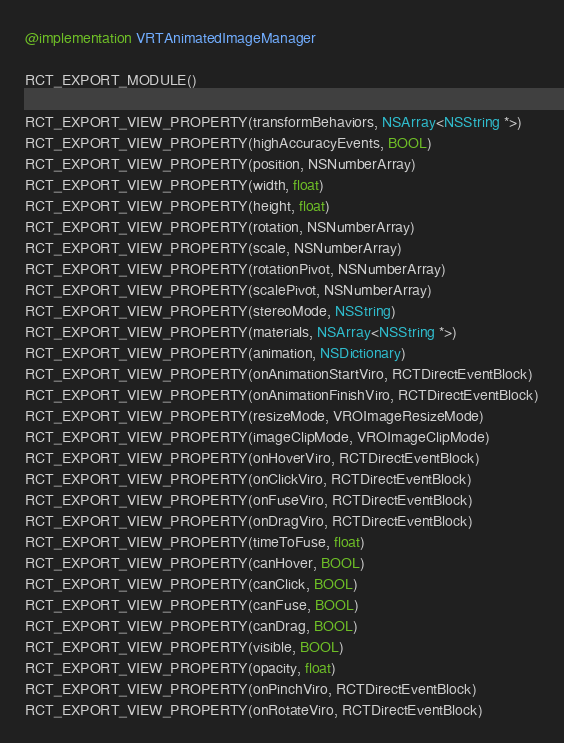Convert code to text. <code><loc_0><loc_0><loc_500><loc_500><_ObjectiveC_>
@implementation VRTAnimatedImageManager

RCT_EXPORT_MODULE()

RCT_EXPORT_VIEW_PROPERTY(transformBehaviors, NSArray<NSString *>)
RCT_EXPORT_VIEW_PROPERTY(highAccuracyEvents, BOOL)
RCT_EXPORT_VIEW_PROPERTY(position, NSNumberArray)
RCT_EXPORT_VIEW_PROPERTY(width, float)
RCT_EXPORT_VIEW_PROPERTY(height, float)
RCT_EXPORT_VIEW_PROPERTY(rotation, NSNumberArray)
RCT_EXPORT_VIEW_PROPERTY(scale, NSNumberArray)
RCT_EXPORT_VIEW_PROPERTY(rotationPivot, NSNumberArray)
RCT_EXPORT_VIEW_PROPERTY(scalePivot, NSNumberArray)
RCT_EXPORT_VIEW_PROPERTY(stereoMode, NSString)
RCT_EXPORT_VIEW_PROPERTY(materials, NSArray<NSString *>)
RCT_EXPORT_VIEW_PROPERTY(animation, NSDictionary)
RCT_EXPORT_VIEW_PROPERTY(onAnimationStartViro, RCTDirectEventBlock)
RCT_EXPORT_VIEW_PROPERTY(onAnimationFinishViro, RCTDirectEventBlock)
RCT_EXPORT_VIEW_PROPERTY(resizeMode, VROImageResizeMode)
RCT_EXPORT_VIEW_PROPERTY(imageClipMode, VROImageClipMode)
RCT_EXPORT_VIEW_PROPERTY(onHoverViro, RCTDirectEventBlock)
RCT_EXPORT_VIEW_PROPERTY(onClickViro, RCTDirectEventBlock)
RCT_EXPORT_VIEW_PROPERTY(onFuseViro, RCTDirectEventBlock)
RCT_EXPORT_VIEW_PROPERTY(onDragViro, RCTDirectEventBlock)
RCT_EXPORT_VIEW_PROPERTY(timeToFuse, float)
RCT_EXPORT_VIEW_PROPERTY(canHover, BOOL)
RCT_EXPORT_VIEW_PROPERTY(canClick, BOOL)
RCT_EXPORT_VIEW_PROPERTY(canFuse, BOOL)
RCT_EXPORT_VIEW_PROPERTY(canDrag, BOOL)
RCT_EXPORT_VIEW_PROPERTY(visible, BOOL)
RCT_EXPORT_VIEW_PROPERTY(opacity, float)
RCT_EXPORT_VIEW_PROPERTY(onPinchViro, RCTDirectEventBlock)
RCT_EXPORT_VIEW_PROPERTY(onRotateViro, RCTDirectEventBlock)</code> 